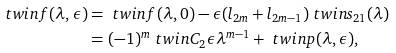<formula> <loc_0><loc_0><loc_500><loc_500>\ t w i n f ( \lambda , \epsilon ) & = \ t w i n f ( \lambda , 0 ) - \epsilon ( l _ { 2 m } + l _ { 2 m - 1 } ) \ t w i n s _ { 2 1 } ( \lambda ) \\ & = ( - 1 ) ^ { m } \ t w i n C _ { 2 } \epsilon \lambda ^ { m - 1 } + \ t w i n p ( \lambda , \epsilon ) ,</formula> 